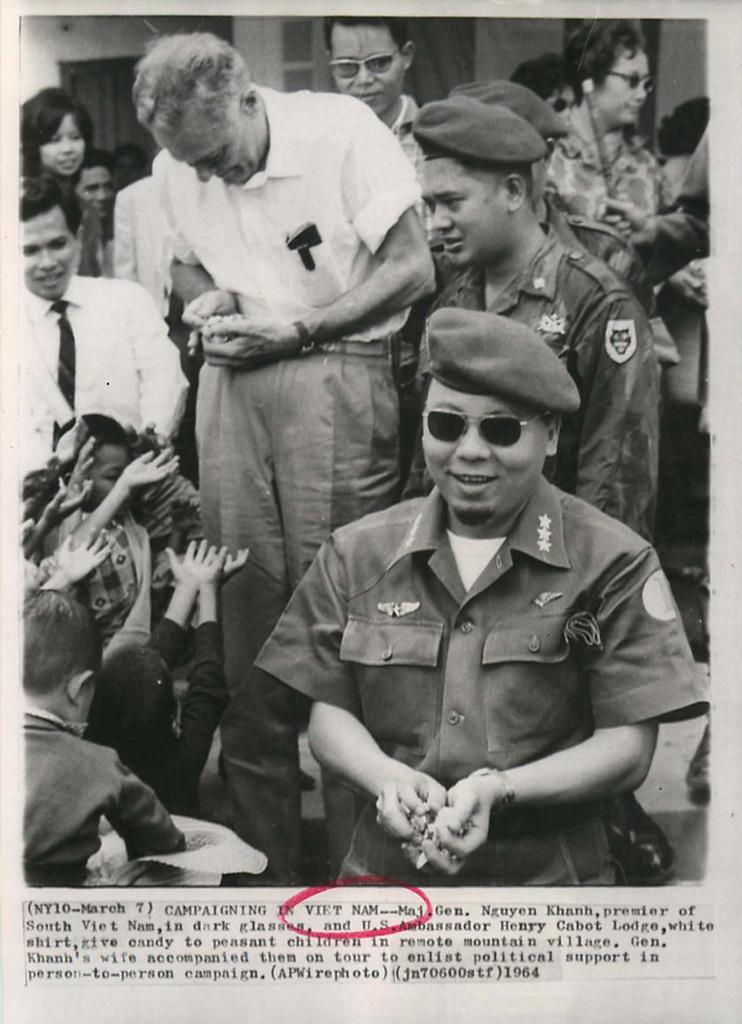Describe this image in one or two sentences. In this image there are so many people standing with a smile on their face, in the background there is a building. At the bottom of the image there is some text. 